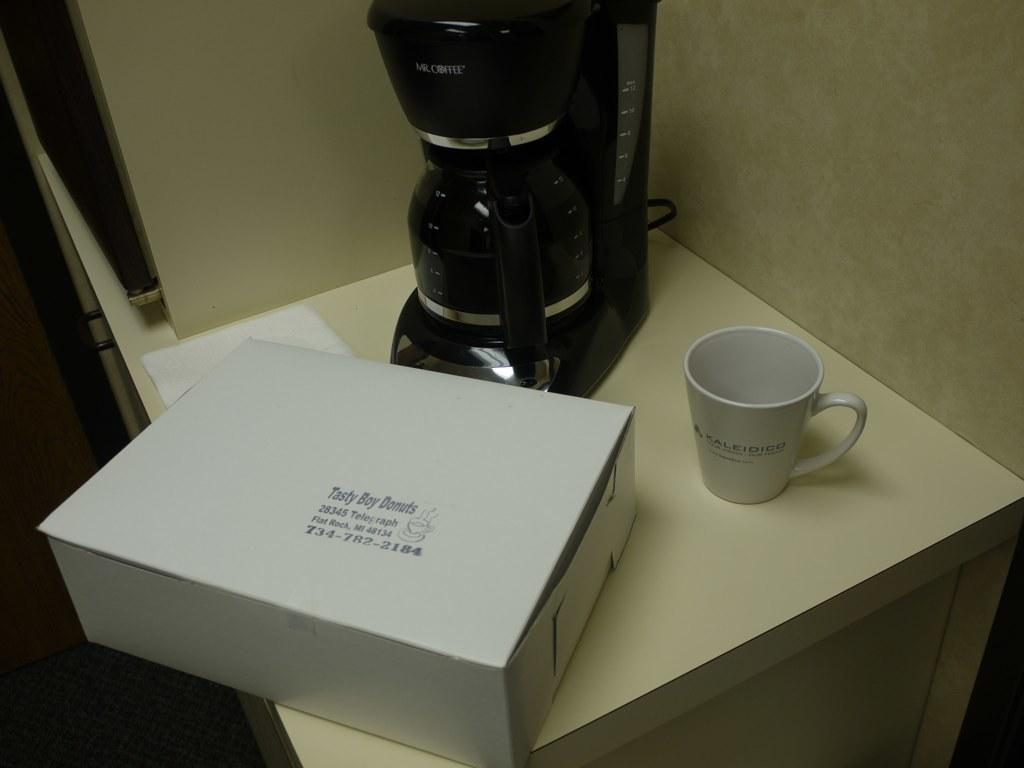Provide a one-sentence caption for the provided image. A plain white box of Tasty Boy Donuts sits on a table near a coffee maker. 